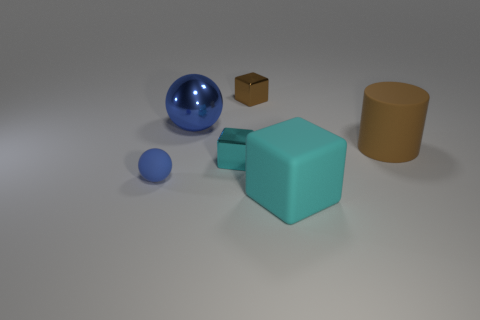Are there more large blue metallic spheres that are to the right of the tiny brown metallic thing than small shiny objects?
Your answer should be very brief. No. The cyan shiny object is what shape?
Your response must be concise. Cube. Do the tiny cube on the right side of the cyan metal thing and the ball that is in front of the big brown rubber cylinder have the same color?
Provide a succinct answer. No. Is the shape of the large cyan rubber object the same as the blue rubber thing?
Your answer should be very brief. No. Is there any other thing that is the same shape as the blue shiny object?
Give a very brief answer. Yes. Does the block that is behind the blue shiny sphere have the same material as the cylinder?
Offer a terse response. No. What is the shape of the shiny thing that is both left of the small brown metal block and behind the cylinder?
Ensure brevity in your answer.  Sphere. Is there a brown thing that is in front of the brown object that is in front of the small brown metal object?
Your response must be concise. No. What number of other objects are there of the same material as the tiny cyan thing?
Offer a terse response. 2. Does the big matte thing in front of the big cylinder have the same shape as the small thing to the left of the big blue ball?
Give a very brief answer. No. 